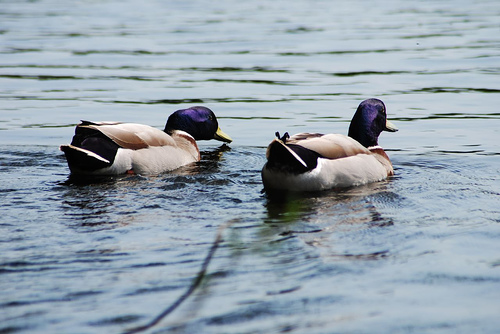<image>
Is the water on the duck? No. The water is not positioned on the duck. They may be near each other, but the water is not supported by or resting on top of the duck. Where is the duck in relation to the duck? Is it to the right of the duck? Yes. From this viewpoint, the duck is positioned to the right side relative to the duck. 